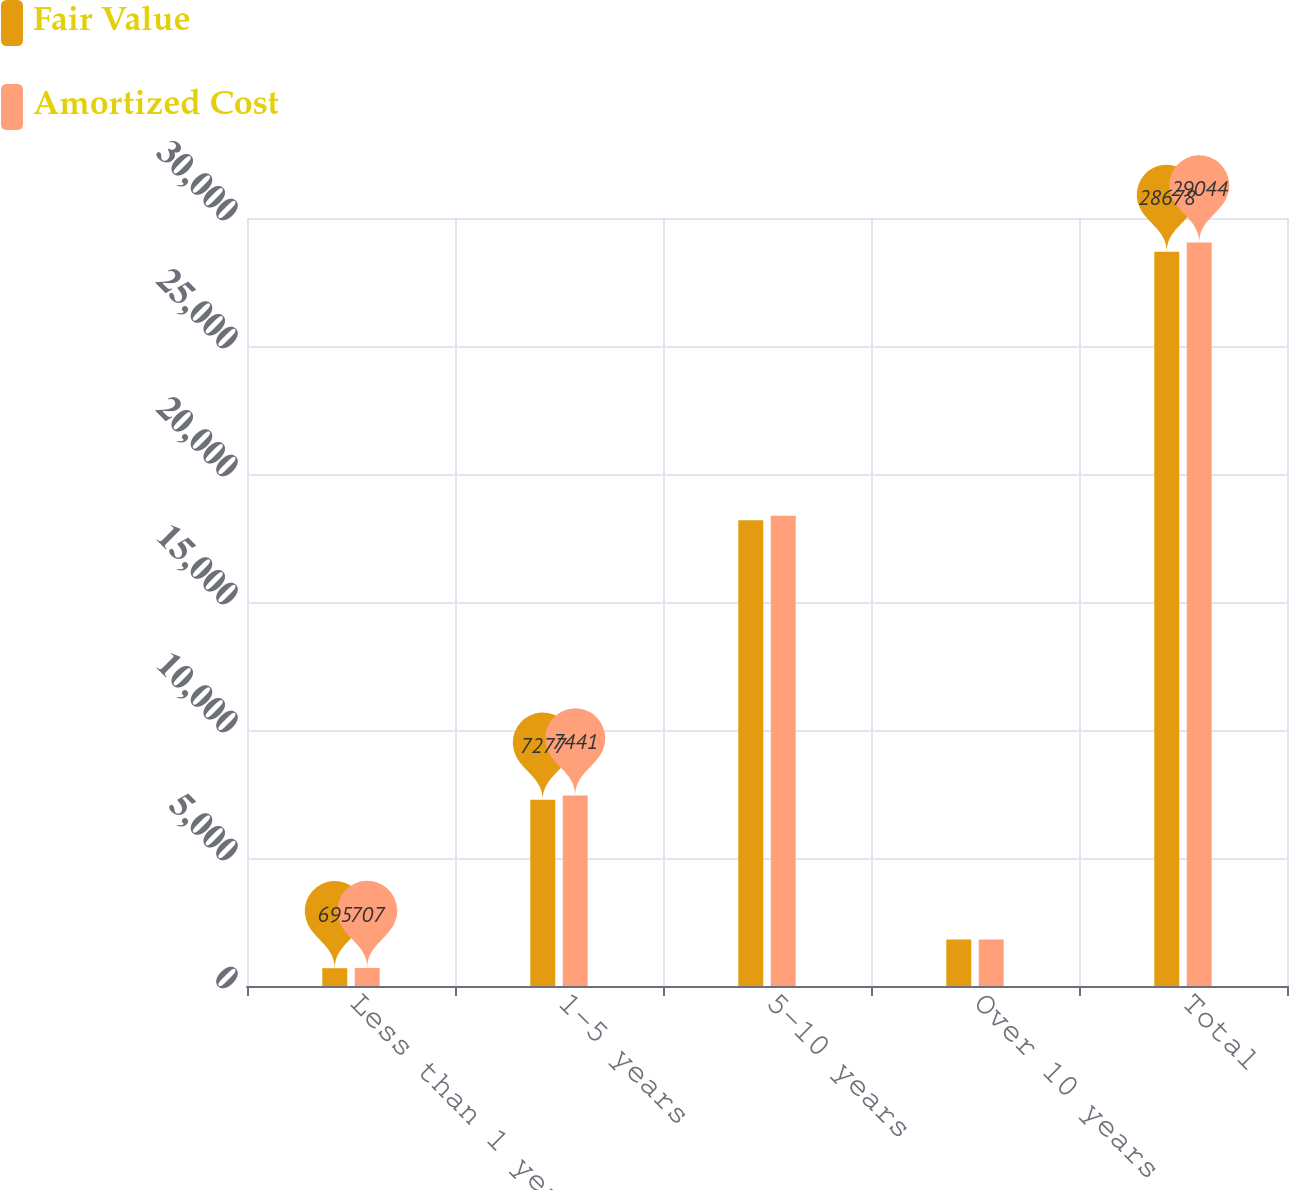Convert chart. <chart><loc_0><loc_0><loc_500><loc_500><stacked_bar_chart><ecel><fcel>Less than 1 year<fcel>1-5 years<fcel>5-10 years<fcel>Over 10 years<fcel>Total<nl><fcel>Fair Value<fcel>695<fcel>7277<fcel>18191<fcel>1812<fcel>28678<nl><fcel>Amortized Cost<fcel>707<fcel>7441<fcel>18372<fcel>1821<fcel>29044<nl></chart> 